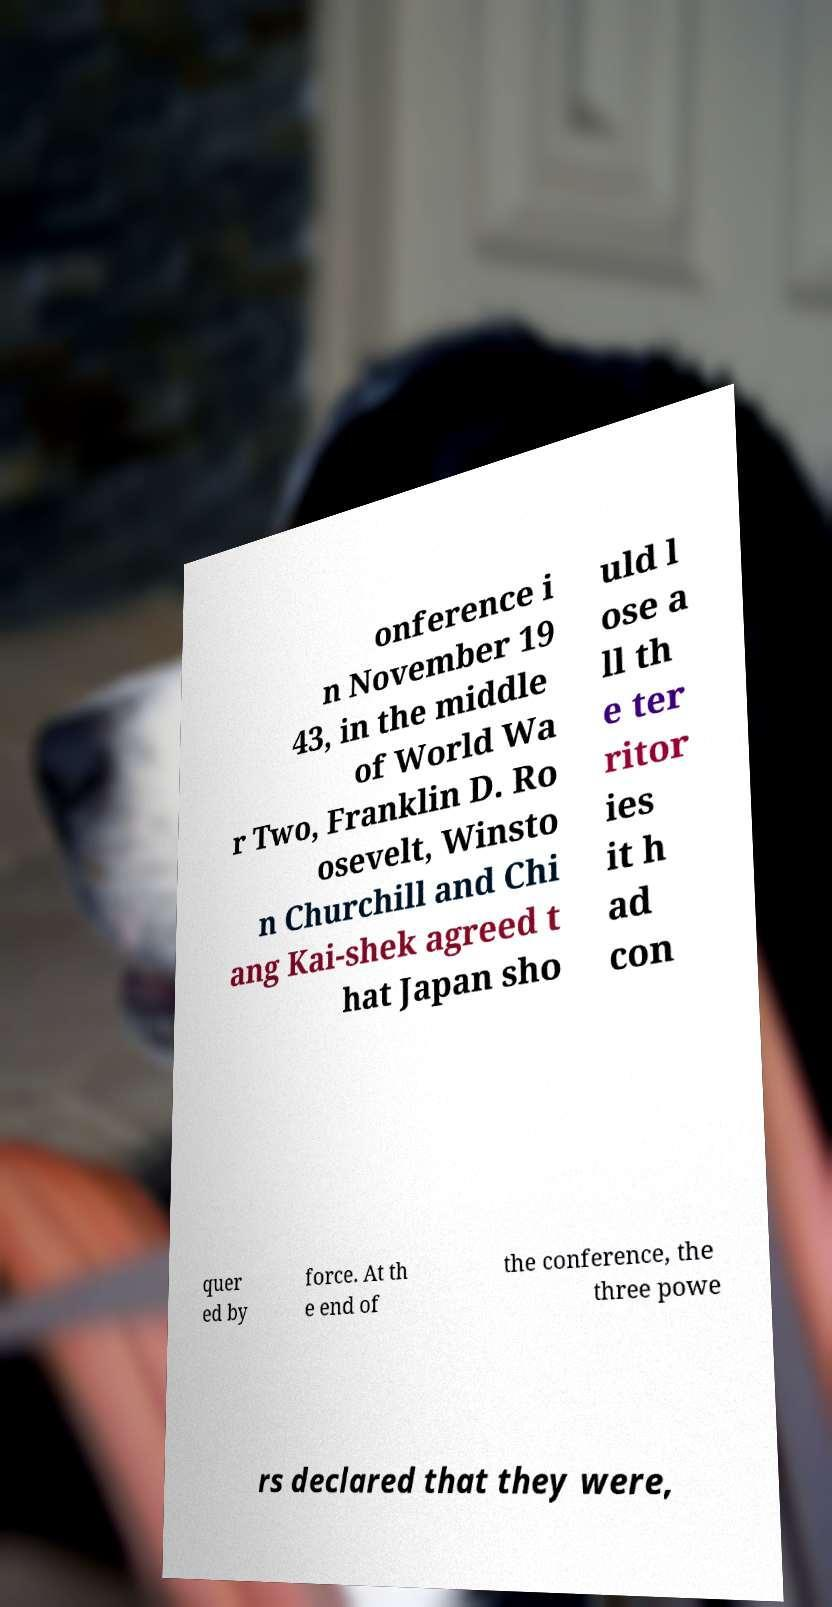What messages or text are displayed in this image? I need them in a readable, typed format. onference i n November 19 43, in the middle of World Wa r Two, Franklin D. Ro osevelt, Winsto n Churchill and Chi ang Kai-shek agreed t hat Japan sho uld l ose a ll th e ter ritor ies it h ad con quer ed by force. At th e end of the conference, the three powe rs declared that they were, 